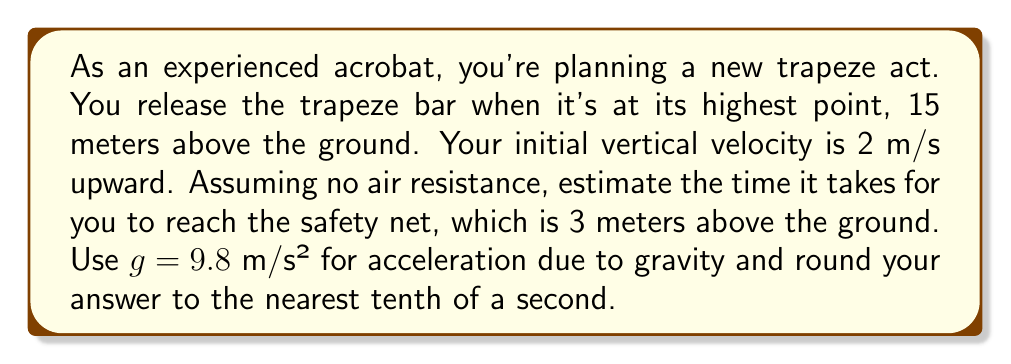What is the answer to this math problem? Let's approach this step-by-step using the equations of motion for an object under constant acceleration (gravity in this case).

1) First, we need to calculate the total distance the acrobat will fall. This is the difference between the initial height and the height of the safety net:
   $$d = 15 \text{ m} - 3 \text{ m} = 12 \text{ m}$$

2) We can use the equation:
   $$d = v_0t + \frac{1}{2}at^2$$
   Where:
   $d$ = distance traveled
   $v_0$ = initial velocity
   $a$ = acceleration (in this case, $-g$ as the acrobat is moving downward)
   $t$ = time

3) Substituting our known values:
   $$12 = 2t - \frac{1}{2}(9.8)t^2$$

4) Rearranging the equation:
   $$4.9t^2 - 2t - 12 = 0$$

5) This is a quadratic equation in the form $at^2 + bt + c = 0$
   We can solve it using the quadratic formula: $$t = \frac{-b \pm \sqrt{b^2 - 4ac}}{2a}$$

6) Substituting our values ($a = 4.9$, $b = -2$, $c = -12$):
   $$t = \frac{2 \pm \sqrt{(-2)^2 - 4(4.9)(-12)}}{2(4.9)}$$

7) Simplifying:
   $$t = \frac{2 \pm \sqrt{4 + 235.2}}{9.8} = \frac{2 \pm \sqrt{239.2}}{9.8}$$

8) Calculating:
   $$t = \frac{2 + 15.47}{9.8} \approx 1.78 \text{ seconds}$$
   (We discard the negative solution as it's not physically meaningful in this context)

9) Rounding to the nearest tenth of a second:
   $$t \approx 1.8 \text{ seconds}$$
Answer: The estimated time of flight for the trapeze artist is 1.8 seconds. 